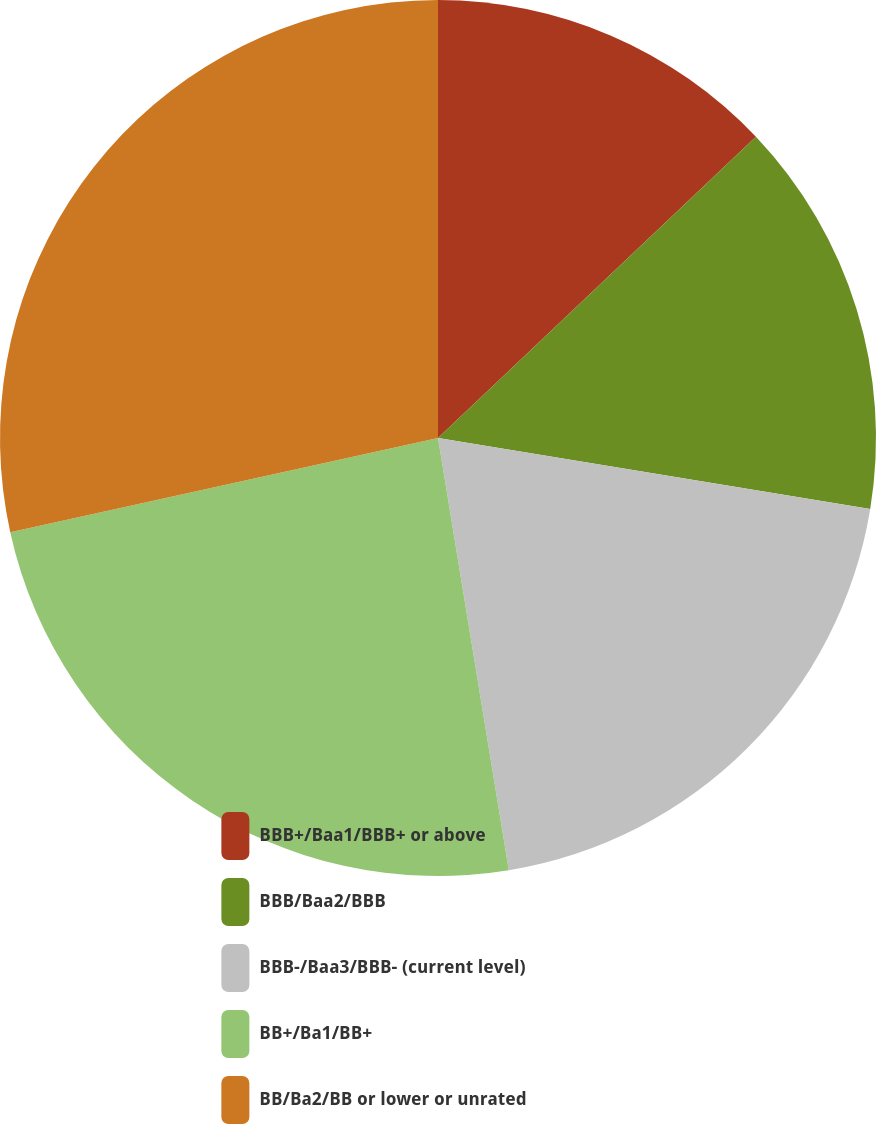Convert chart. <chart><loc_0><loc_0><loc_500><loc_500><pie_chart><fcel>BBB+/Baa1/BBB+ or above<fcel>BBB/Baa2/BBB<fcel>BBB-/Baa3/BBB- (current level)<fcel>BB+/Ba1/BB+<fcel>BB/Ba2/BB or lower or unrated<nl><fcel>12.93%<fcel>14.66%<fcel>19.83%<fcel>24.14%<fcel>28.45%<nl></chart> 